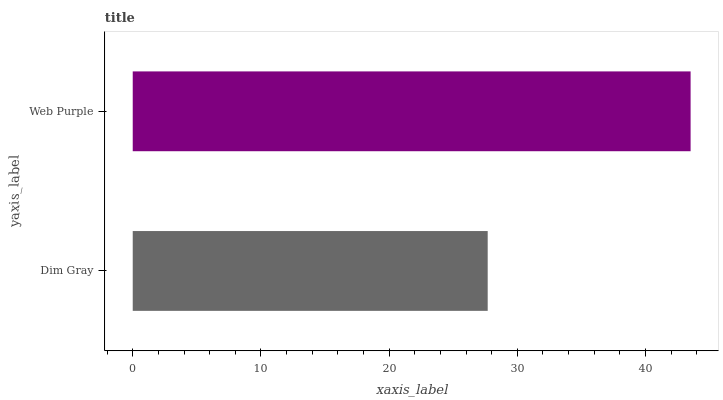Is Dim Gray the minimum?
Answer yes or no. Yes. Is Web Purple the maximum?
Answer yes or no. Yes. Is Web Purple the minimum?
Answer yes or no. No. Is Web Purple greater than Dim Gray?
Answer yes or no. Yes. Is Dim Gray less than Web Purple?
Answer yes or no. Yes. Is Dim Gray greater than Web Purple?
Answer yes or no. No. Is Web Purple less than Dim Gray?
Answer yes or no. No. Is Web Purple the high median?
Answer yes or no. Yes. Is Dim Gray the low median?
Answer yes or no. Yes. Is Dim Gray the high median?
Answer yes or no. No. Is Web Purple the low median?
Answer yes or no. No. 